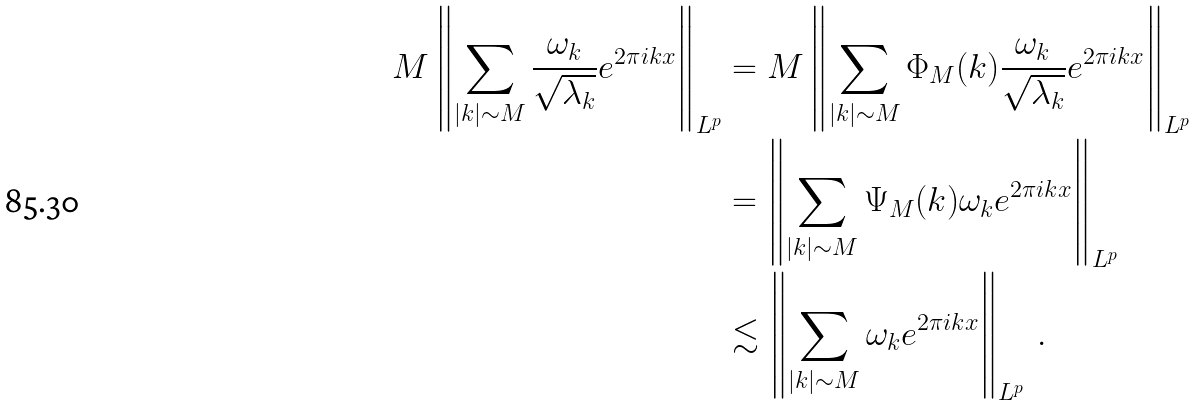<formula> <loc_0><loc_0><loc_500><loc_500>M \left \| \sum _ { | k | \sim M } \frac { \omega _ { k } } { \sqrt { \lambda _ { k } } } e ^ { 2 \pi i k x } \right \| _ { L ^ { p } } & = M \left \| \sum _ { | k | \sim M } \Phi _ { M } ( k ) \frac { \omega _ { k } } { \sqrt { \lambda _ { k } } } e ^ { 2 \pi i k x } \right \| _ { L ^ { p } } \\ & = \left \| \sum _ { | k | \sim M } \Psi _ { M } ( k ) \omega _ { k } e ^ { 2 \pi i k x } \right \| _ { L ^ { p } } \\ & \lesssim \left \| \sum _ { | k | \sim M } \omega _ { k } e ^ { 2 \pi i k x } \right \| _ { L ^ { p } } \, .</formula> 